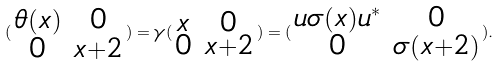<formula> <loc_0><loc_0><loc_500><loc_500>( \begin{smallmatrix} \theta ( x ) & 0 \\ 0 & x + 2 \end{smallmatrix} ) = \gamma ( \begin{smallmatrix} x & 0 \\ 0 & x + 2 \end{smallmatrix} ) = ( \begin{smallmatrix} u \sigma ( x ) u ^ { * } & 0 \\ 0 & \sigma ( x + 2 ) \end{smallmatrix} ) .</formula> 